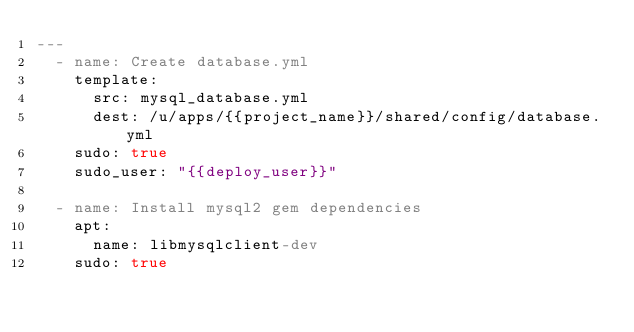Convert code to text. <code><loc_0><loc_0><loc_500><loc_500><_YAML_>---
  - name: Create database.yml
    template:
      src: mysql_database.yml
      dest: /u/apps/{{project_name}}/shared/config/database.yml
    sudo: true
    sudo_user: "{{deploy_user}}"

  - name: Install mysql2 gem dependencies
    apt:
      name: libmysqlclient-dev
    sudo: true
</code> 